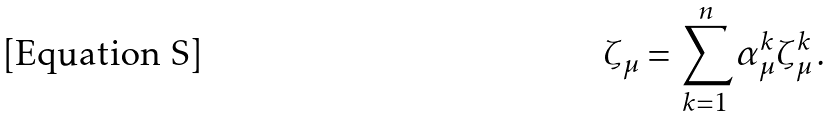<formula> <loc_0><loc_0><loc_500><loc_500>\zeta _ { \mu } = \sum _ { k = 1 } ^ { n } \alpha _ { \mu } ^ { k } \zeta _ { \mu } ^ { k } \, .</formula> 